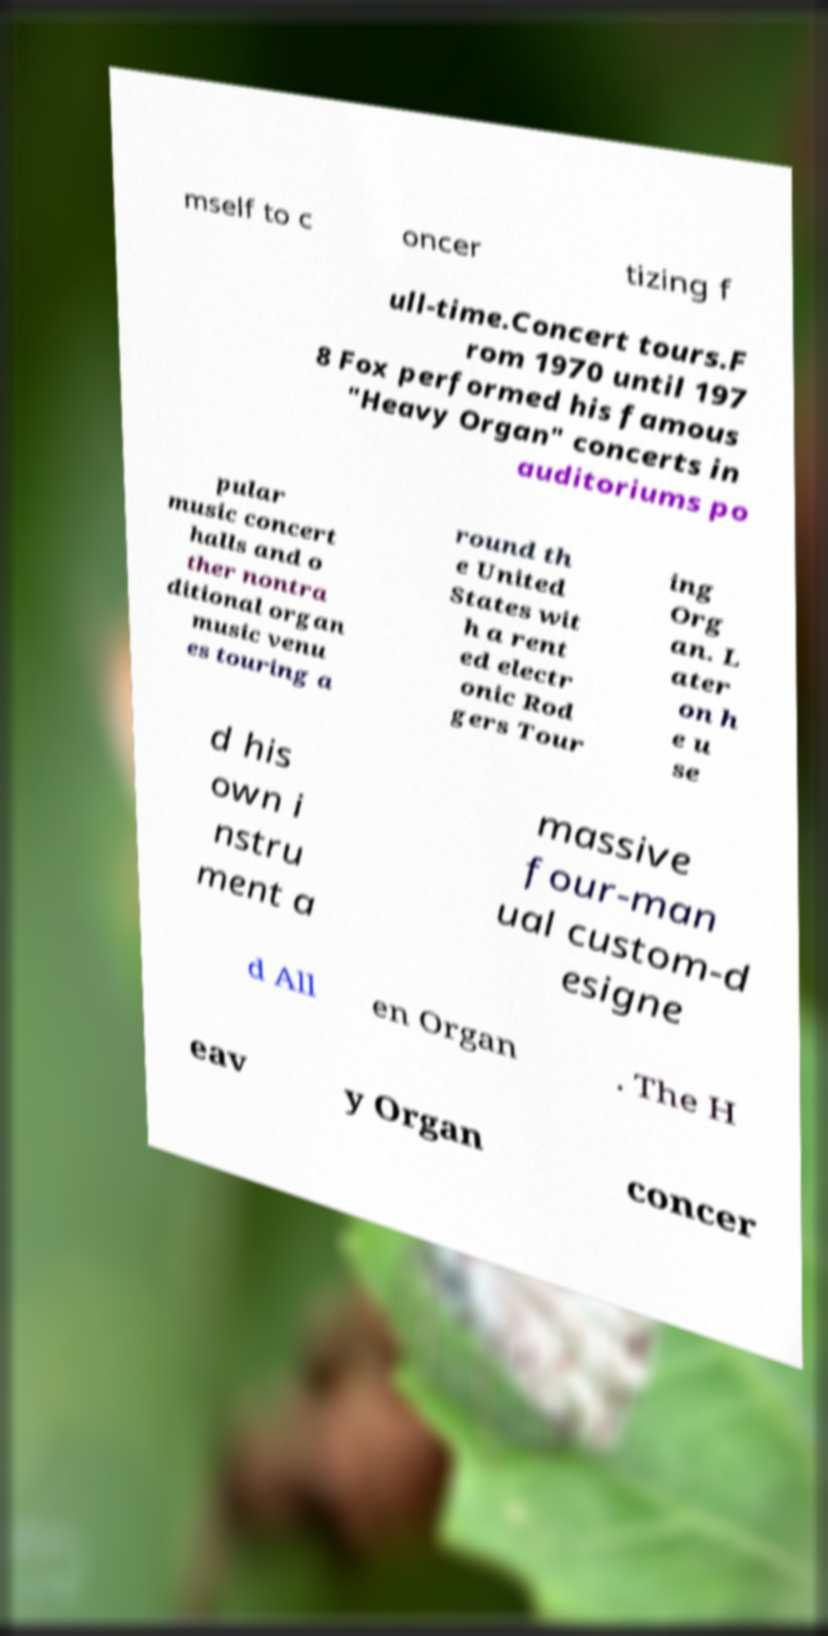Could you assist in decoding the text presented in this image and type it out clearly? mself to c oncer tizing f ull-time.Concert tours.F rom 1970 until 197 8 Fox performed his famous "Heavy Organ" concerts in auditoriums po pular music concert halls and o ther nontra ditional organ music venu es touring a round th e United States wit h a rent ed electr onic Rod gers Tour ing Org an. L ater on h e u se d his own i nstru ment a massive four-man ual custom-d esigne d All en Organ . The H eav y Organ concer 